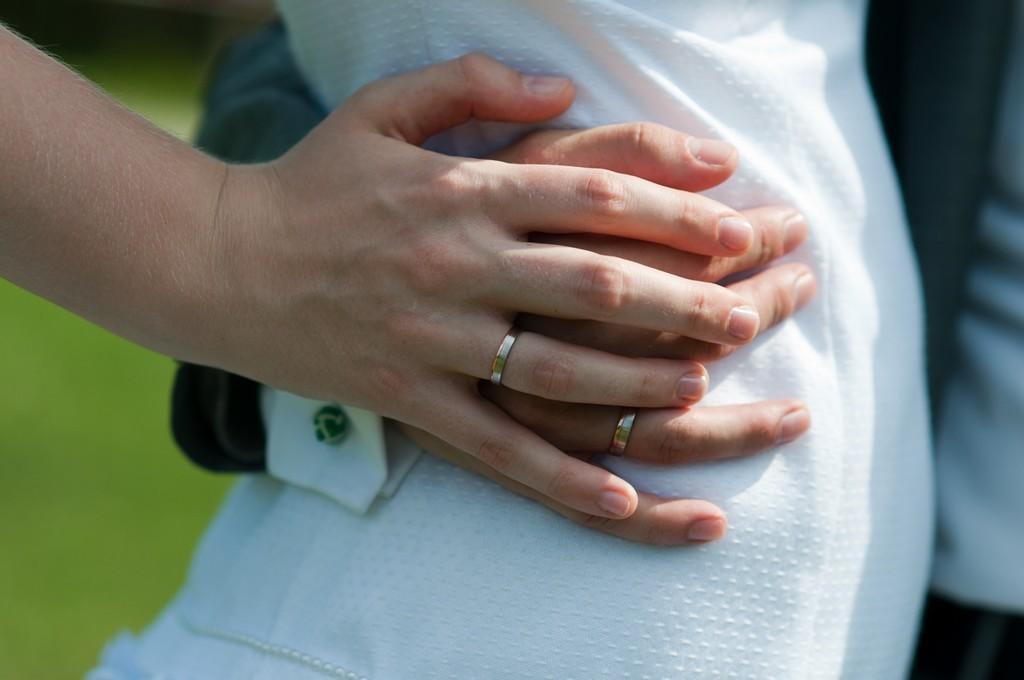In one or two sentences, can you explain what this image depicts? In the center of the image there are two persons hands. 